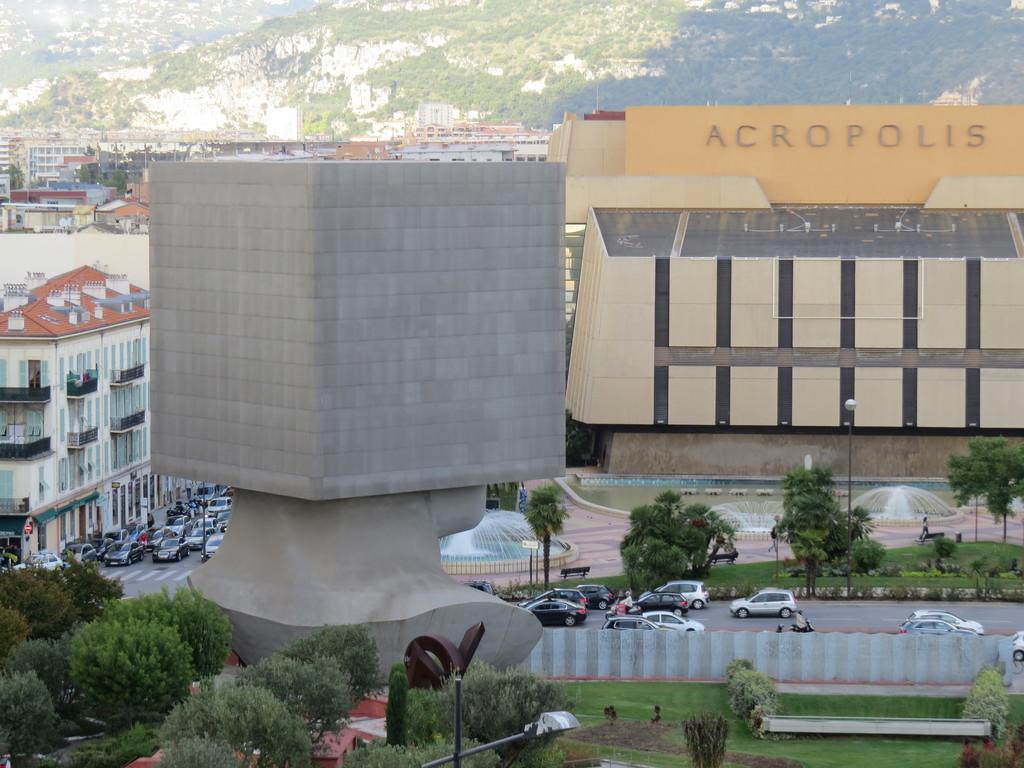Please provide a concise description of this image. In this image we can see buildings, motor vehicles, fountains, hills, road, ground, bushes, trees and benches on the ground. 